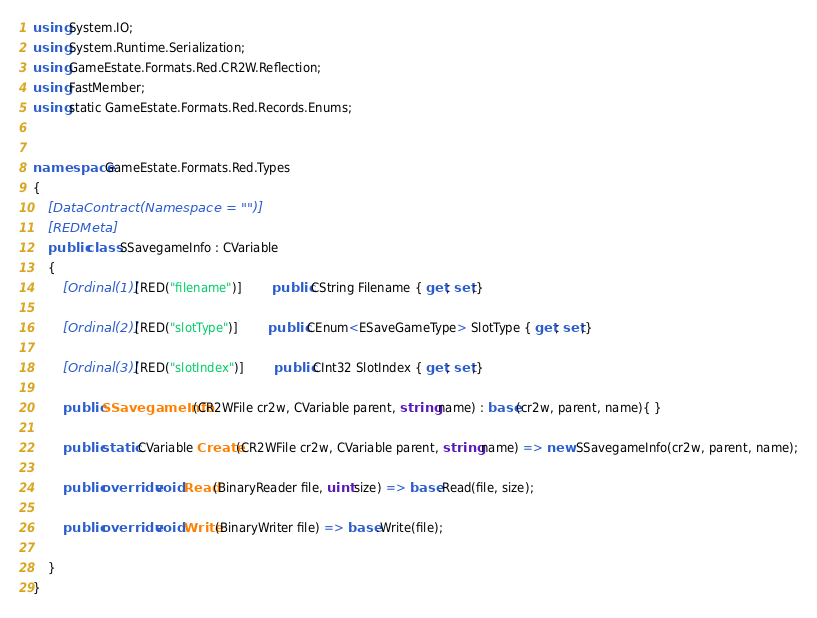<code> <loc_0><loc_0><loc_500><loc_500><_C#_>using System.IO;
using System.Runtime.Serialization;
using GameEstate.Formats.Red.CR2W.Reflection;
using FastMember;
using static GameEstate.Formats.Red.Records.Enums;


namespace GameEstate.Formats.Red.Types
{
	[DataContract(Namespace = "")]
	[REDMeta]
	public class SSavegameInfo : CVariable
	{
		[Ordinal(1)] [RED("filename")] 		public CString Filename { get; set;}

		[Ordinal(2)] [RED("slotType")] 		public CEnum<ESaveGameType> SlotType { get; set;}

		[Ordinal(3)] [RED("slotIndex")] 		public CInt32 SlotIndex { get; set;}

		public SSavegameInfo(CR2WFile cr2w, CVariable parent, string name) : base(cr2w, parent, name){ }

		public static CVariable Create(CR2WFile cr2w, CVariable parent, string name) => new SSavegameInfo(cr2w, parent, name);

		public override void Read(BinaryReader file, uint size) => base.Read(file, size);

		public override void Write(BinaryWriter file) => base.Write(file);

	}
}</code> 